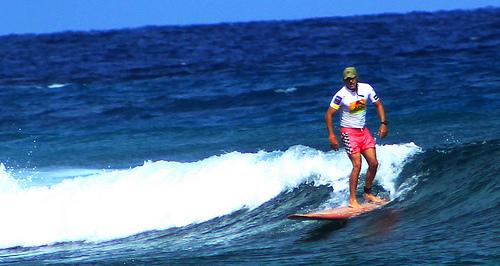Question: what is the man doing?
Choices:
A. Surfing.
B. Eating.
C. Sleeping.
D. Skiing.
Answer with the letter. Answer: A Question: what color shorts is the man wearing?
Choices:
A. White.
B. Green.
C. Red.
D. Yellow.
Answer with the letter. Answer: C Question: where is the man surfing?
Choices:
A. River.
B. Ocean.
C. Snow.
D. Ramp.
Answer with the letter. Answer: B Question: when was this photo taken?
Choices:
A. At night.
B. In winter.
C. In the afternoon.
D. At sunset.
Answer with the letter. Answer: C 